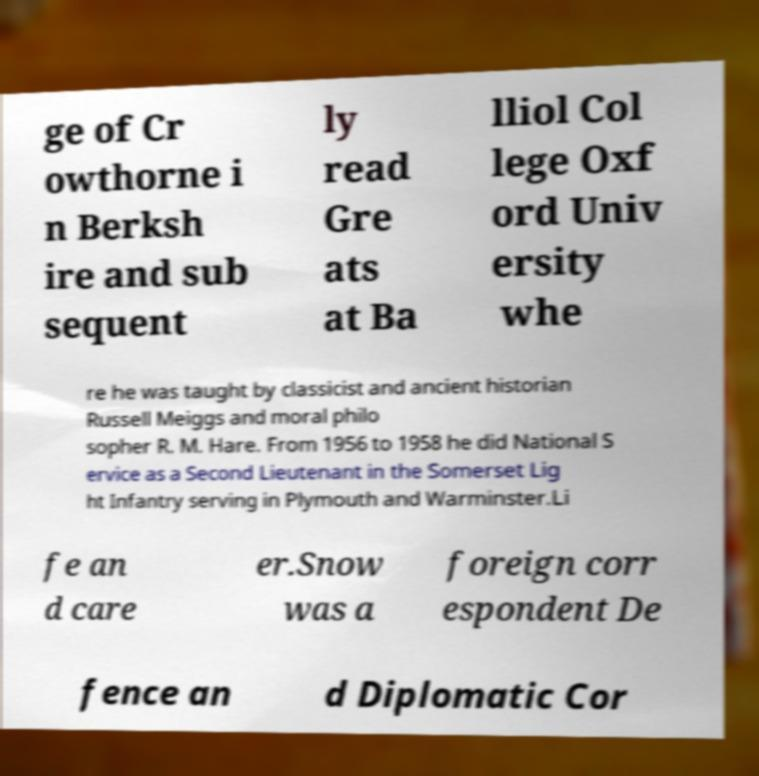Can you read and provide the text displayed in the image?This photo seems to have some interesting text. Can you extract and type it out for me? ge of Cr owthorne i n Berksh ire and sub sequent ly read Gre ats at Ba lliol Col lege Oxf ord Univ ersity whe re he was taught by classicist and ancient historian Russell Meiggs and moral philo sopher R. M. Hare. From 1956 to 1958 he did National S ervice as a Second Lieutenant in the Somerset Lig ht Infantry serving in Plymouth and Warminster.Li fe an d care er.Snow was a foreign corr espondent De fence an d Diplomatic Cor 